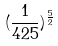<formula> <loc_0><loc_0><loc_500><loc_500>( \frac { 1 } { 4 2 5 } ) ^ { \frac { 5 } { 2 } }</formula> 